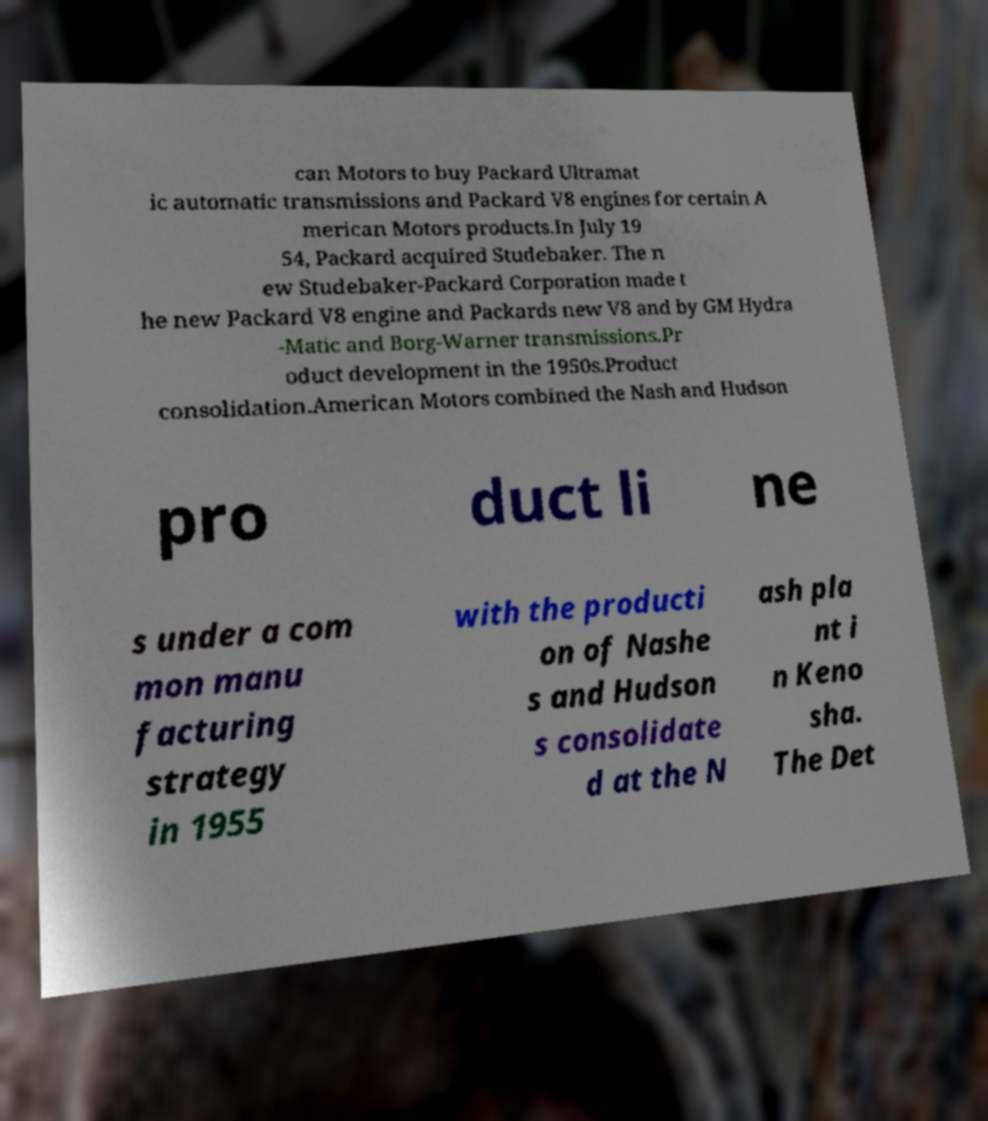I need the written content from this picture converted into text. Can you do that? can Motors to buy Packard Ultramat ic automatic transmissions and Packard V8 engines for certain A merican Motors products.In July 19 54, Packard acquired Studebaker. The n ew Studebaker-Packard Corporation made t he new Packard V8 engine and Packards new V8 and by GM Hydra -Matic and Borg-Warner transmissions.Pr oduct development in the 1950s.Product consolidation.American Motors combined the Nash and Hudson pro duct li ne s under a com mon manu facturing strategy in 1955 with the producti on of Nashe s and Hudson s consolidate d at the N ash pla nt i n Keno sha. The Det 